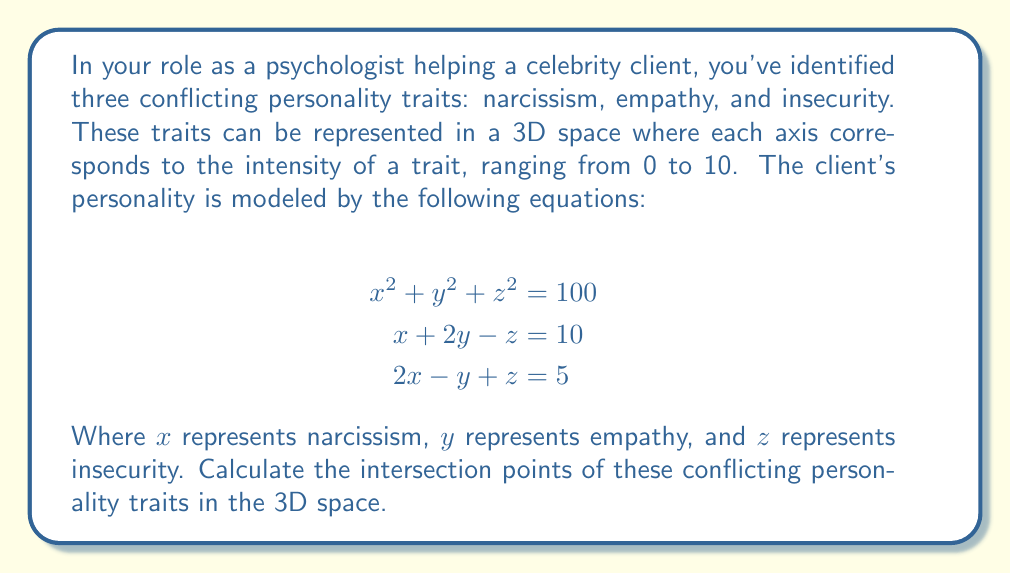Provide a solution to this math problem. To solve this problem, we need to find the points that satisfy all three equations simultaneously. Let's approach this step-by-step:

1) We have a system of three equations:
   $$\begin{align}
   x^2 + y^2 + z^2 &= 100 \tag{1}\\
   x + 2y - z &= 10 \tag{2}\\
   2x - y + z &= 5 \tag{3}
   \end{align}$$

2) From equations (2) and (3), we can express $z$ in terms of $x$ and $y$:
   From (2): $z = x + 2y - 10$ \tag{4}
   From (3): $z = 5 - 2x + y$ \tag{5}

3) Equating (4) and (5):
   $x + 2y - 10 = 5 - 2x + y$
   $3x + y = 15$
   $y = 15 - 3x$ \tag{6}

4) Substitute (6) into (4):
   $z = x + 2(15 - 3x) - 10 = 30 - 5x - 10 = 20 - 5x$ \tag{7}

5) Now, substitute (6) and (7) into equation (1):
   $x^2 + (15 - 3x)^2 + (20 - 5x)^2 = 100$

6) Expand this equation:
   $x^2 + 225 - 90x + 9x^2 + 400 - 200x + 25x^2 = 100$
   $35x^2 - 290x + 525 = 0$

7) This is a quadratic equation. Solve it using the quadratic formula:
   $x = \frac{290 \pm \sqrt{290^2 - 4(35)(525)}}{2(35)}$
   $x = \frac{290 \pm \sqrt{84100 - 73500}}{70}$
   $x = \frac{290 \pm \sqrt{10600}}{70}$
   $x = \frac{290 \pm 103}{70}$

8) This gives us two solutions for $x$:
   $x_1 = \frac{290 + 103}{70} = \frac{393}{70} \approx 5.61$
   $x_2 = \frac{290 - 103}{70} = \frac{187}{70} \approx 2.67$

9) For each $x$, calculate the corresponding $y$ and $z$ using equations (6) and (7):
   For $x_1$: 
   $y_1 = 15 - 3(\frac{393}{70}) = \frac{1050 - 1179}{70} = -\frac{129}{70} \approx -1.84$
   $z_1 = 20 - 5(\frac{393}{70}) = \frac{1400 - 1965}{70} = -\frac{565}{70} \approx -8.07$

   For $x_2$:
   $y_2 = 15 - 3(\frac{187}{70}) = \frac{1050 - 561}{70} = \frac{489}{70} \approx 6.99$
   $z_2 = 20 - 5(\frac{187}{70}) = \frac{1400 - 935}{70} = \frac{465}{70} \approx 6.64$

Therefore, the two intersection points are $(\frac{393}{70}, -\frac{129}{70}, -\frac{565}{70})$ and $(\frac{187}{70}, \frac{489}{70}, \frac{465}{70})$.
Answer: $(\frac{393}{70}, -\frac{129}{70}, -\frac{565}{70})$ and $(\frac{187}{70}, \frac{489}{70}, \frac{465}{70})$ 